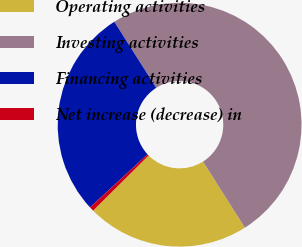<chart> <loc_0><loc_0><loc_500><loc_500><pie_chart><fcel>Operating activities<fcel>Investing activities<fcel>Financing activities<fcel>Net increase (decrease) in<nl><fcel>21.55%<fcel>50.0%<fcel>27.87%<fcel>0.58%<nl></chart> 